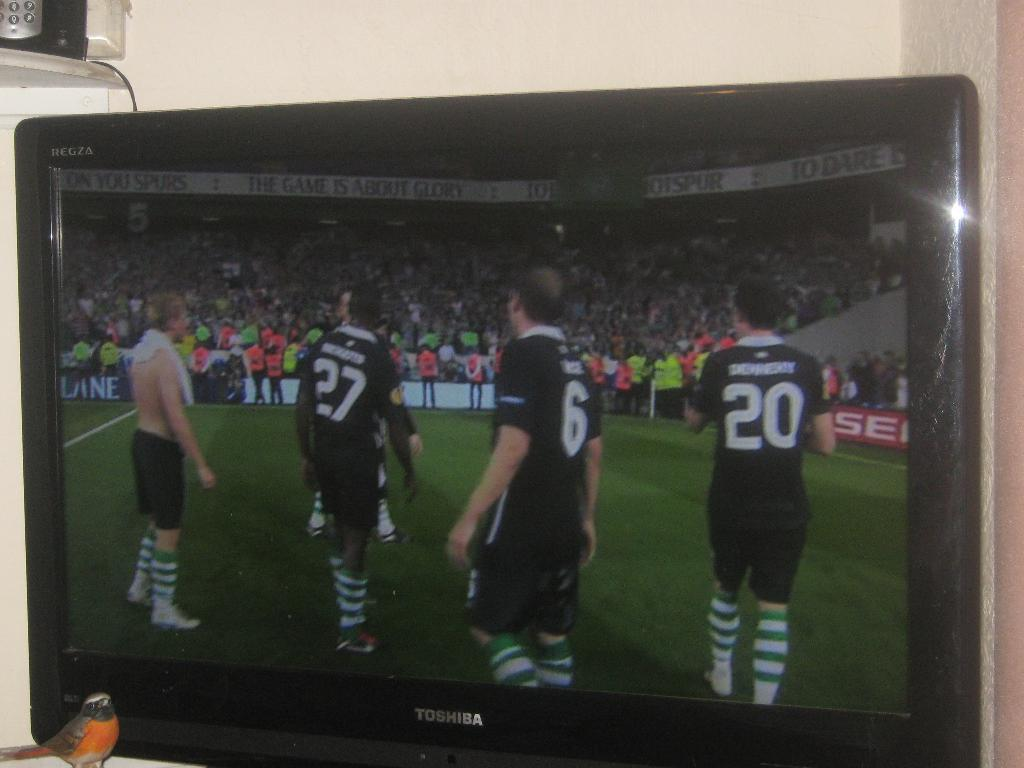<image>
Provide a brief description of the given image. Players stand on the field as viewed on a TV made by Toshiba. 